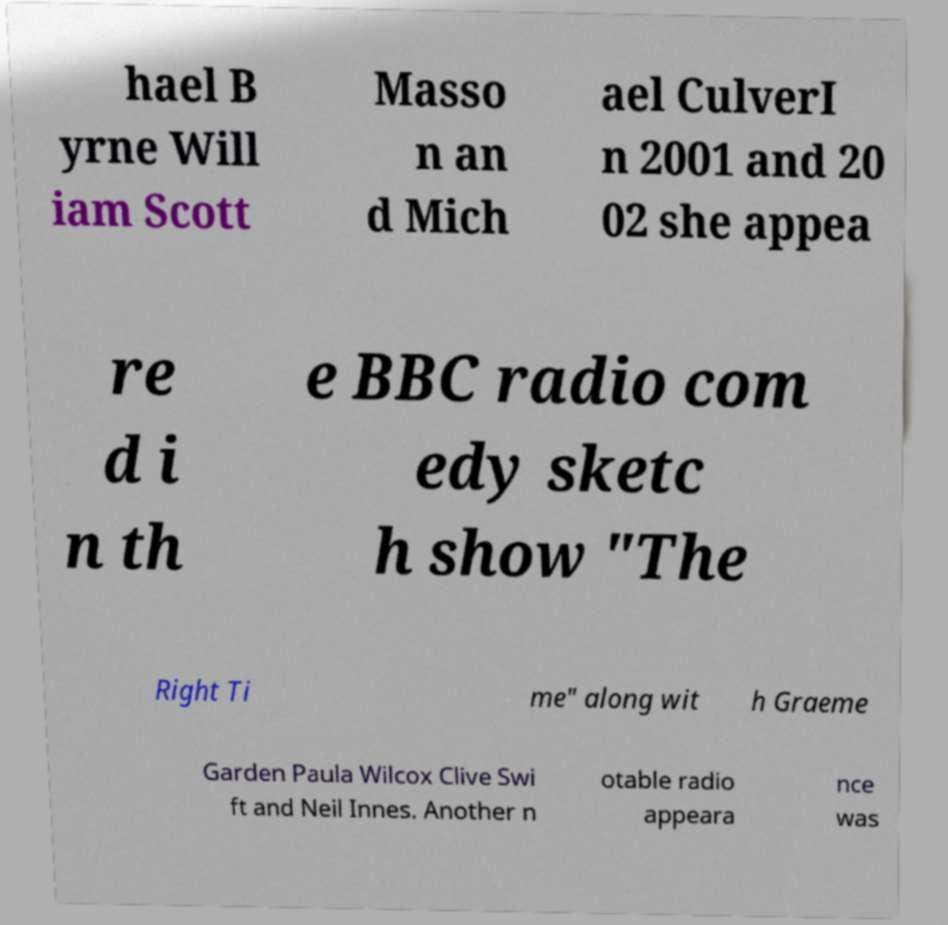Please read and relay the text visible in this image. What does it say? hael B yrne Will iam Scott Masso n an d Mich ael CulverI n 2001 and 20 02 she appea re d i n th e BBC radio com edy sketc h show "The Right Ti me" along wit h Graeme Garden Paula Wilcox Clive Swi ft and Neil Innes. Another n otable radio appeara nce was 